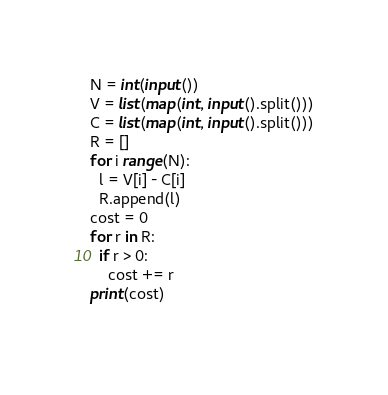<code> <loc_0><loc_0><loc_500><loc_500><_Python_>N = int(input())
V = list(map(int, input().split()))
C = list(map(int, input().split()))
R = []
for i range(N):
  l = V[i] - C[i]
  R.append(l)
cost = 0
for r in R:
  if r > 0:
    cost += r
print(cost)
  
</code> 